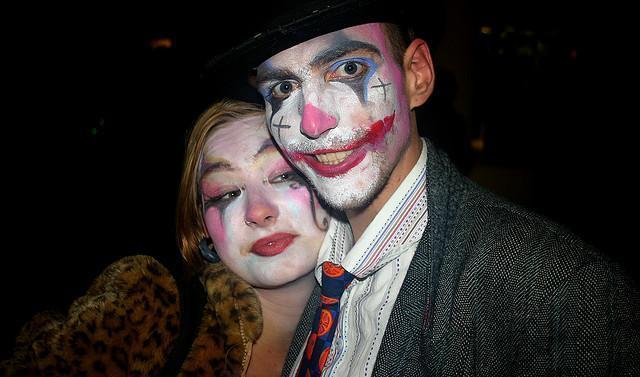What is the red thing near the man's mouth?
Indicate the correct response and explain using: 'Answer: answer
Rationale: rationale.'
Options: Paint, beet juice, blood, ketchup. Answer: paint.
Rationale: Paint is used when making your face look like a clown. 